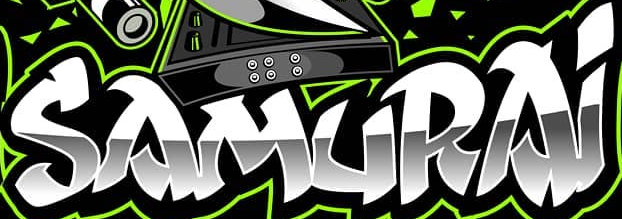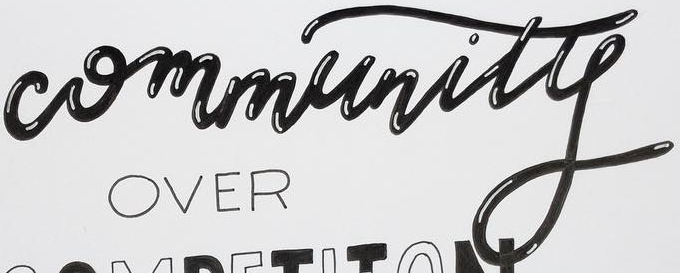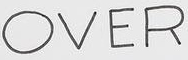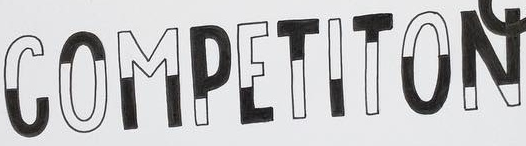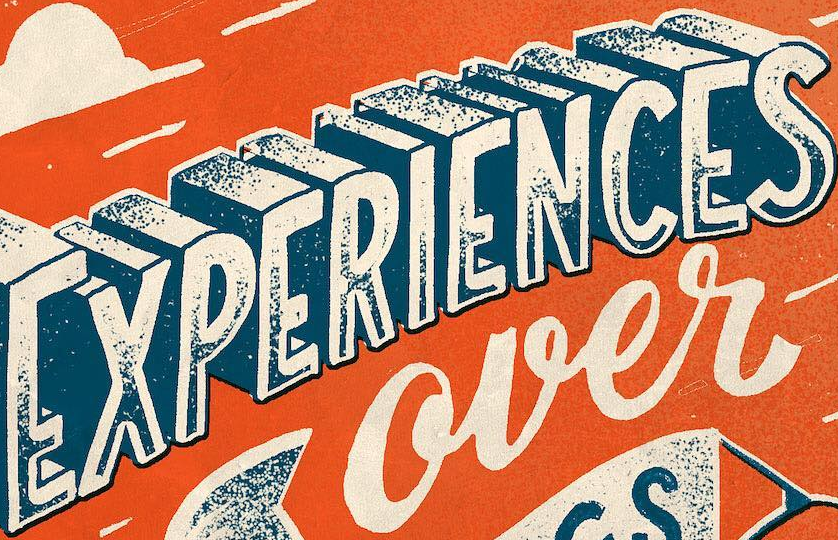What text appears in these images from left to right, separated by a semicolon? SAMURAi; Community; OVER; COMPETITON; EXPERIENCES 